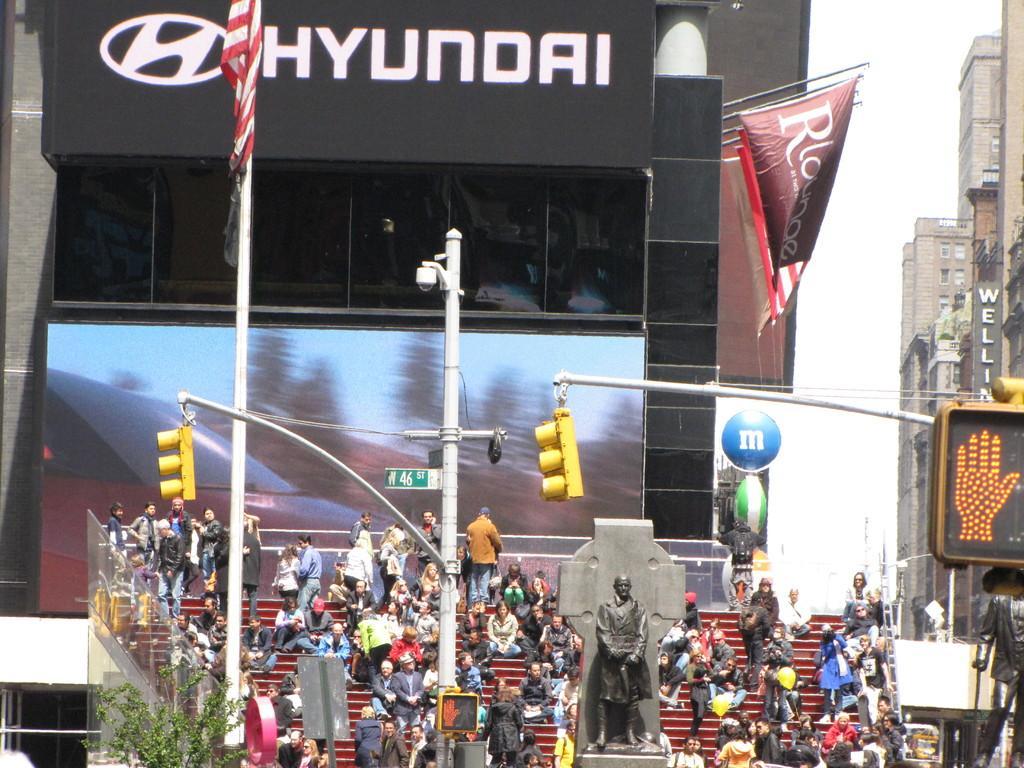Describe this image in one or two sentences. In this image I can see group of people, some are standing and some are sitting. In front I can see a statue in black color and I can also see few traffic signals, background I can see few banners attached to the poles and I can see buildings in brown and cream color and the sky is in white color. 